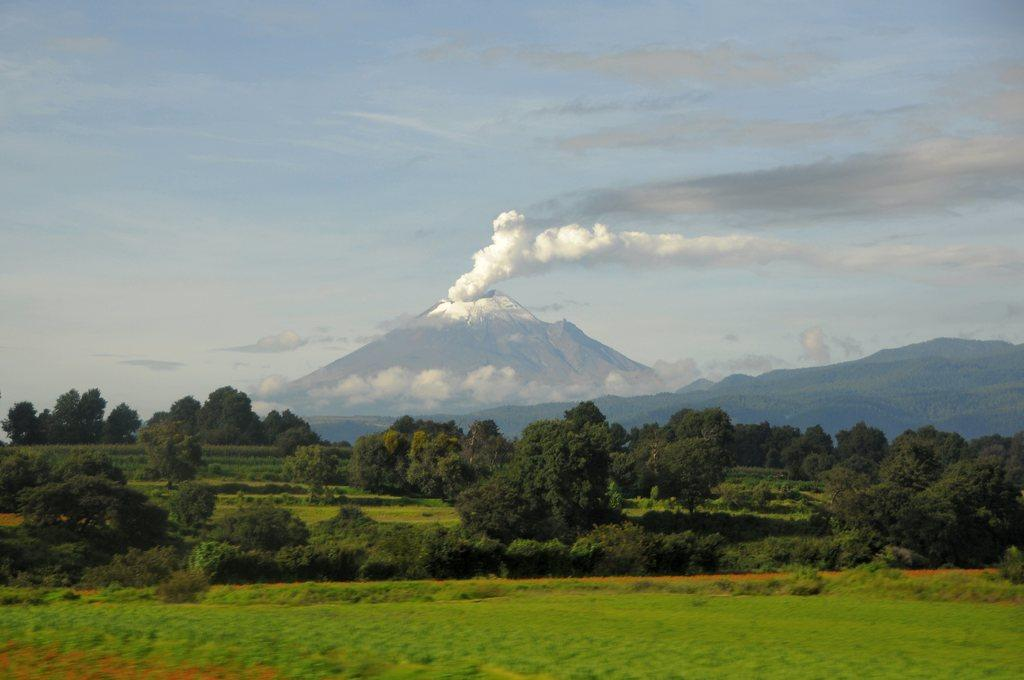What type of vegetation can be seen in the image? There are trees in the image. What is covering the ground in the image? There is grass on the ground in the image. What geological feature is visible in the background of the image? There is a volcano in the background of the image. What can be seen in the sky in the background of the image? There are clouds in the sky in the background of the image. What type of skin condition can be seen on the trees in the image? There is no mention of any skin condition on the trees in the image; they appear to be healthy. 